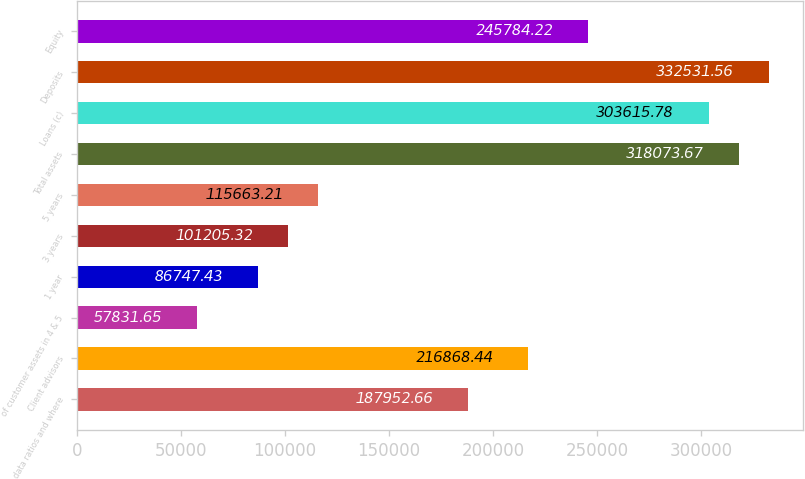Convert chart. <chart><loc_0><loc_0><loc_500><loc_500><bar_chart><fcel>data ratios and where<fcel>Client advisors<fcel>of customer assets in 4 & 5<fcel>1 year<fcel>3 years<fcel>5 years<fcel>Total assets<fcel>Loans (c)<fcel>Deposits<fcel>Equity<nl><fcel>187953<fcel>216868<fcel>57831.7<fcel>86747.4<fcel>101205<fcel>115663<fcel>318074<fcel>303616<fcel>332532<fcel>245784<nl></chart> 